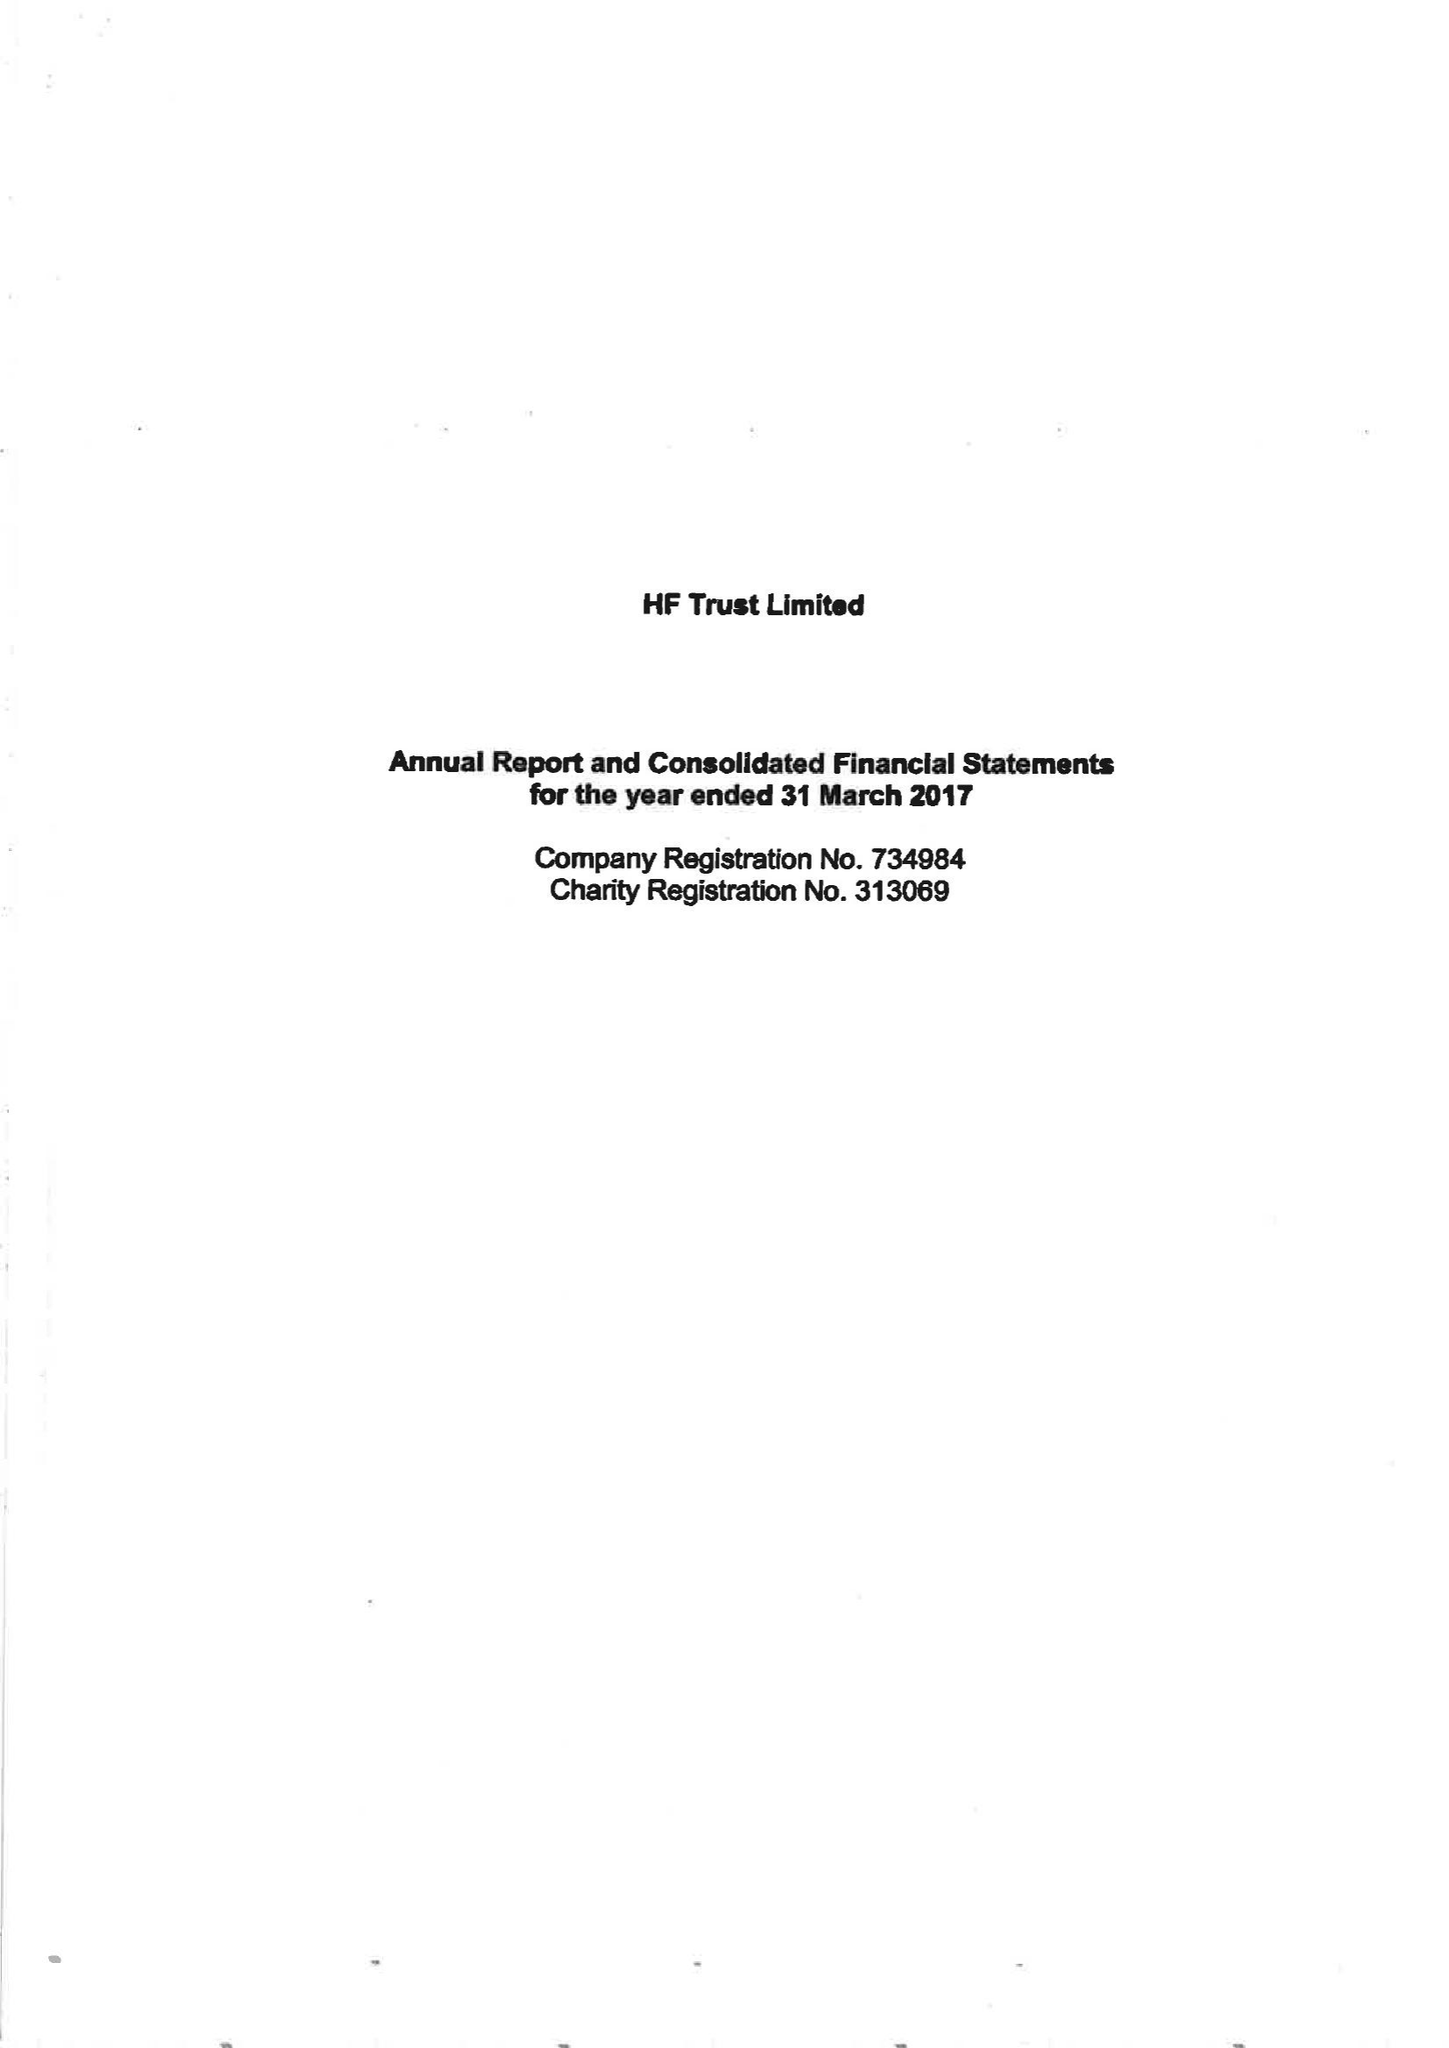What is the value for the income_annually_in_british_pounds?
Answer the question using a single word or phrase. 78257000.00 